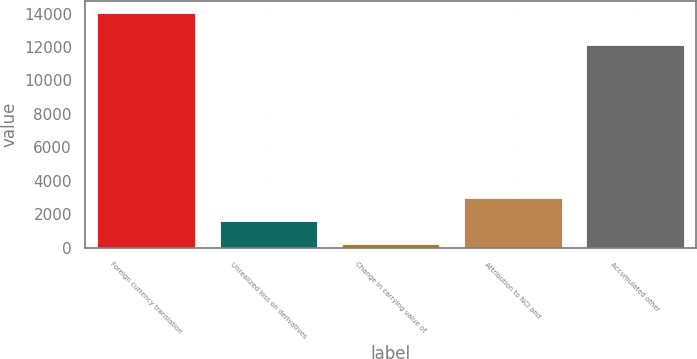<chart> <loc_0><loc_0><loc_500><loc_500><bar_chart><fcel>Foreign currency translation<fcel>Unrealized loss on derivatives<fcel>Change in carrying value of<fcel>Attribution to NCI and<fcel>Accumulated other<nl><fcel>14027<fcel>1611.5<fcel>232<fcel>2991<fcel>12100<nl></chart> 